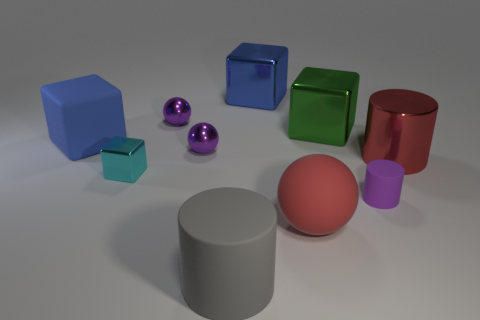How many purple objects are there?
Provide a succinct answer. 3. Is there a big gray rubber cylinder behind the purple shiny object in front of the blue thing that is left of the large gray thing?
Keep it short and to the point. No. There is a blue metal thing that is the same size as the gray object; what is its shape?
Your response must be concise. Cube. What number of other objects are the same color as the tiny rubber cylinder?
Offer a terse response. 2. What material is the gray thing?
Your answer should be compact. Rubber. What number of other objects are there of the same material as the cyan object?
Give a very brief answer. 5. What is the size of the metal cube that is in front of the blue shiny thing and right of the big gray cylinder?
Provide a succinct answer. Large. There is a blue thing that is behind the blue block that is on the left side of the big gray thing; what is its shape?
Your response must be concise. Cube. Is there any other thing that has the same shape as the green metal thing?
Your answer should be compact. Yes. Are there the same number of tiny spheres that are behind the metallic cylinder and small green metallic objects?
Ensure brevity in your answer.  No. 